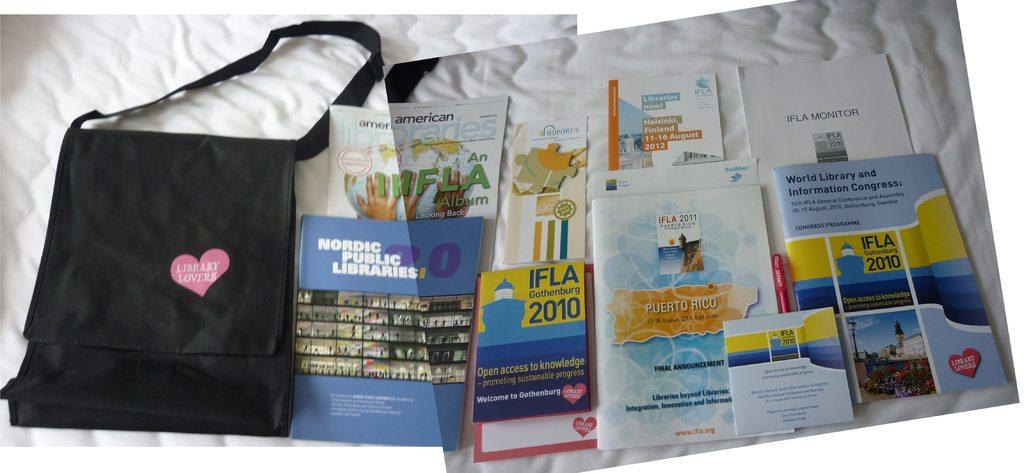What object can be seen in the picture? There is a bag in the picture. What is located on the bed in the image? There are books on the bed. What phrase is written on the bag? The bag has the words "library lovers" written on it. Can you see a robin jumping on the bag in the image? No, there is no robin or jumping depicted in the image. 